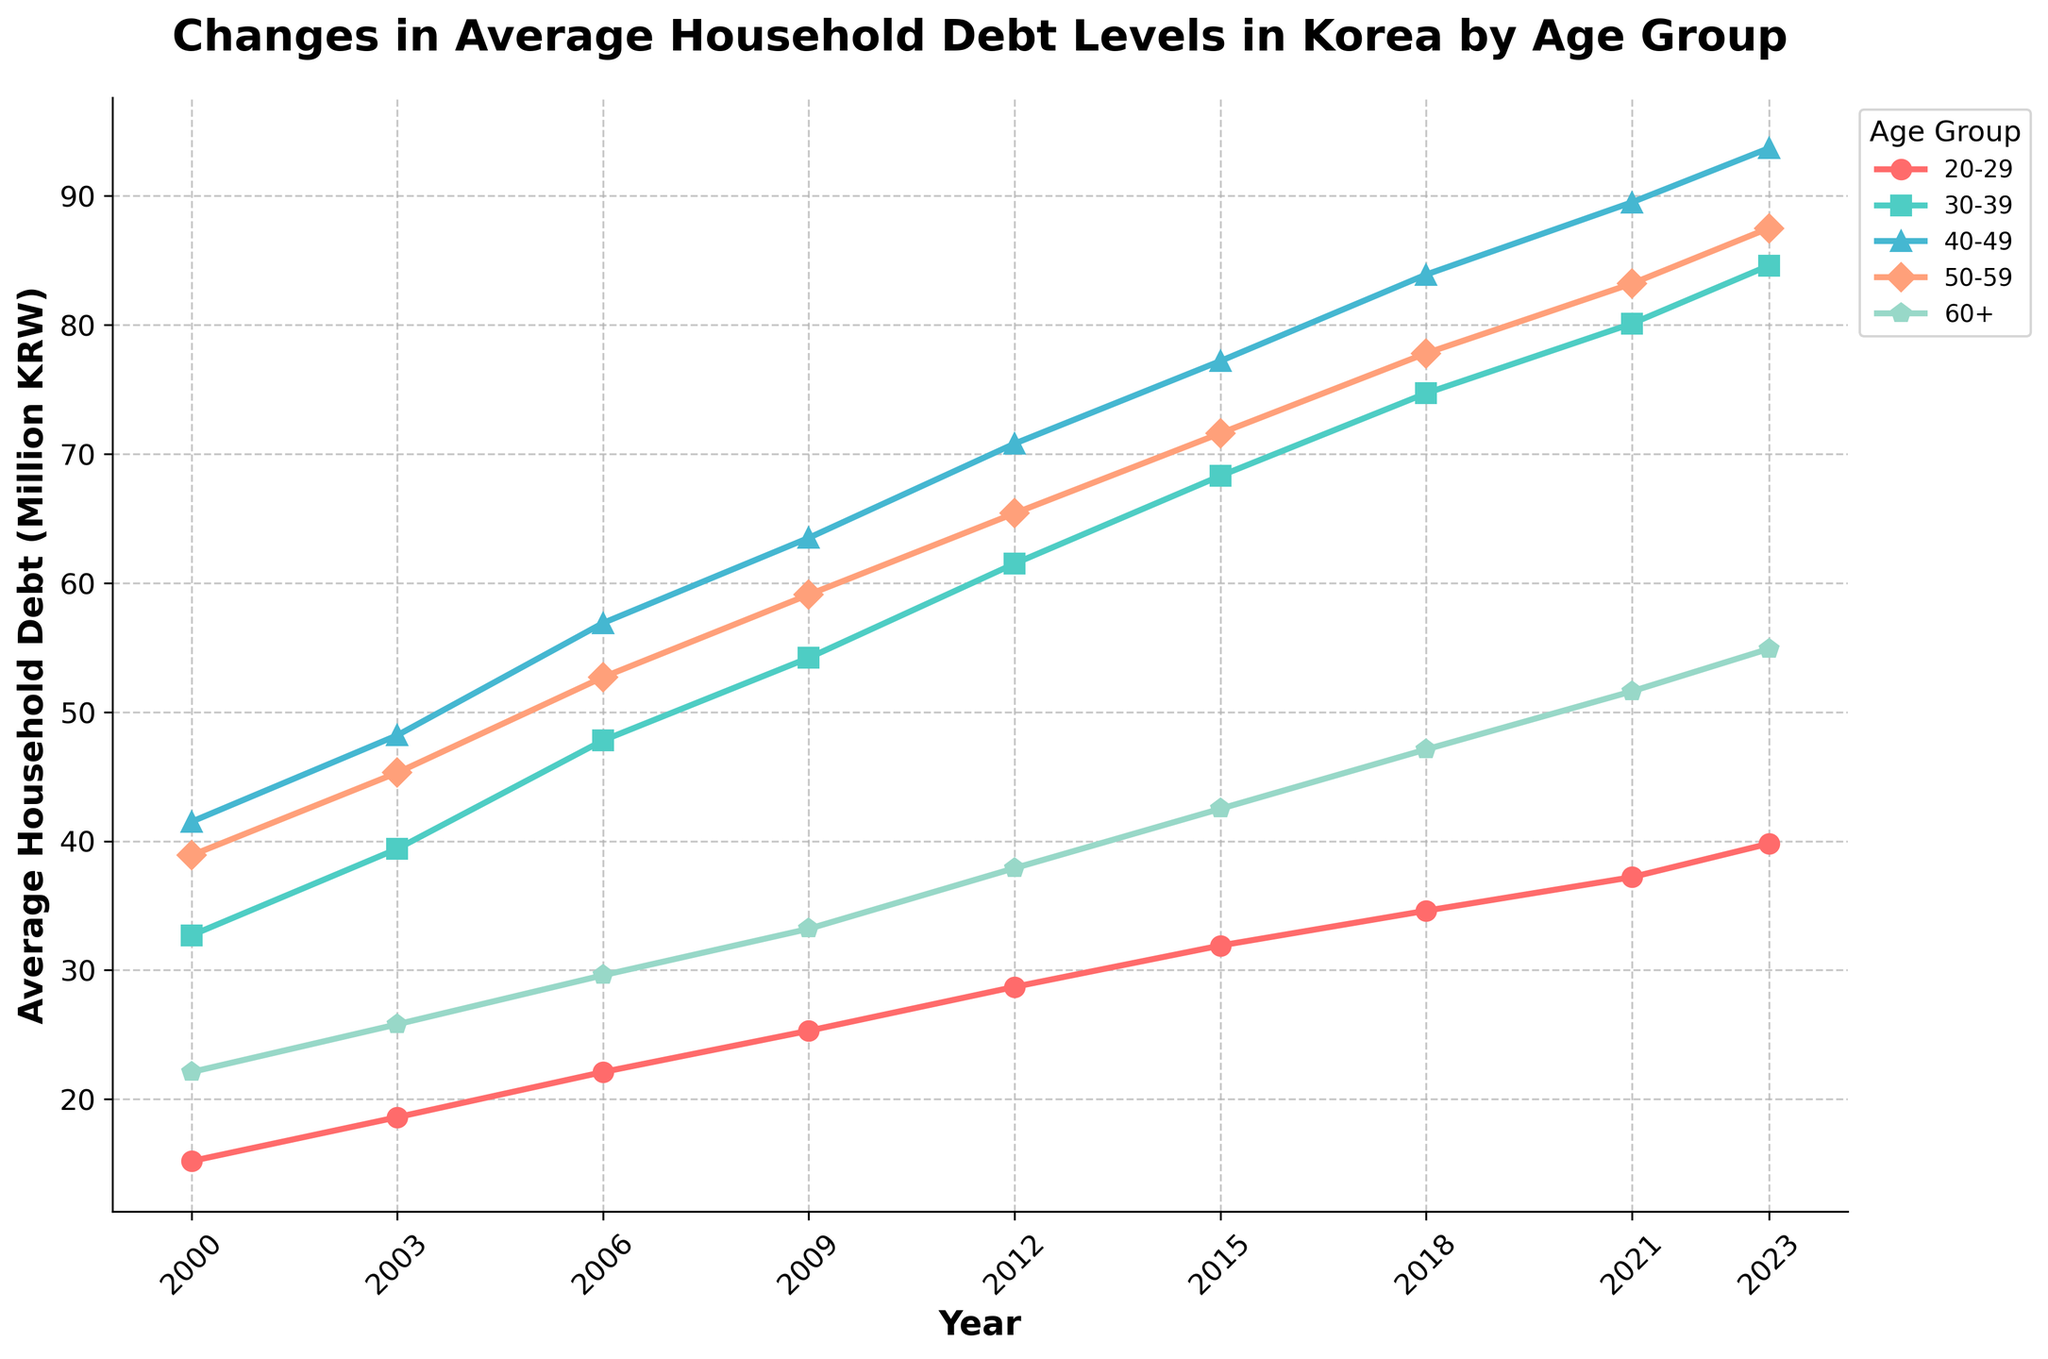What age group had the highest household debt in 2023? By examining the final data points of each line in 2023, we observe that the 40-49 age group has the highest value at 93.7 million KRW, which is higher than all other age groups
Answer: 40-49 Which age group showed the most significant increase in average household debt from 2000 to 2023? The increase for each age group is calculated by subtracting the 2000 value from the 2023 value: (20-29: 39.8-15.2=24.6), (30-39: 84.6-32.7=51.9), (40-49: 93.7-41.5=52.2), (50-59: 87.5-38.9=48.6), (60+: 54.9-22.1=32.8). The 40-49 age group has the highest increase of 52.2 million KRW
Answer: 40-49 Which age group had the smallest household debt in 2000? Evaluating the 2000 data points for all age groups, the smallest value is 15.2 million KRW for the 20-29 age group
Answer: 20-29 By how much did the average household debt for the 60+ age group increase from 2018 to 2021? The debt levels in 2018 and 2021 for the 60+ age group are 47.1 and 51.6 million KRW respectively. The increase is calculated as 51.6 - 47.1 = 4.5 million KRW
Answer: 4.5 million KRW In which year did the 30-39 age group surpass an average household debt of 50 million KRW? By examining the data points for the 30-39 age group, they surpassed 50 million KRW in 2006 when their average debt reached 47.8 million KRW and 54.2 million KRW in 2009. Therefore, it was in 2009
Answer: 2009 Comparing the 50-59 and 60+ age groups, which group had a higher rate of debt increase from 2000 to 2023? The rate of increase is calculated as (value in 2023 - value in 2000) / value in 2000. For 50-59: (87.5-38.9)/38.9 = 48.6/38.9 ≈ 1.25. For 60+: (54.9-22.1)/22.1 = 32.8/22.1 ≈ 1.48. Therefore, the 60+ age group had a higher rate of increase
Answer: 60+ What is the trend in average debt levels for the 20-29 age group from 2000 to 2023? By observing the line for the 20-29 age group from 2000 to 2023, we see a consistent upward trajectory indicating a continuous increase in average debt levels
Answer: Upward trend In which years did the average household debt of the 30-39 age group increase by more than 5 million KRW compared to the previous year? We check the differences in consecutive years: (2003-2000: 39.4-32.7=6.7), (2006-2003: 47.8-39.4=8.4), (2009-2006: 54.2-47.8=6.4), (2012-2009: 61.5-54.2=7.3), (2015-2012: 68.3-61.5=6.8), (2018-2015: 74.7-68.3=6.4), (2021-2018: 80.1-74.7=5.4). All these years show an increase of more than 5 million KRW
Answer: 2003, 2006, 2009, 2012, 2015, 2018, 2021 